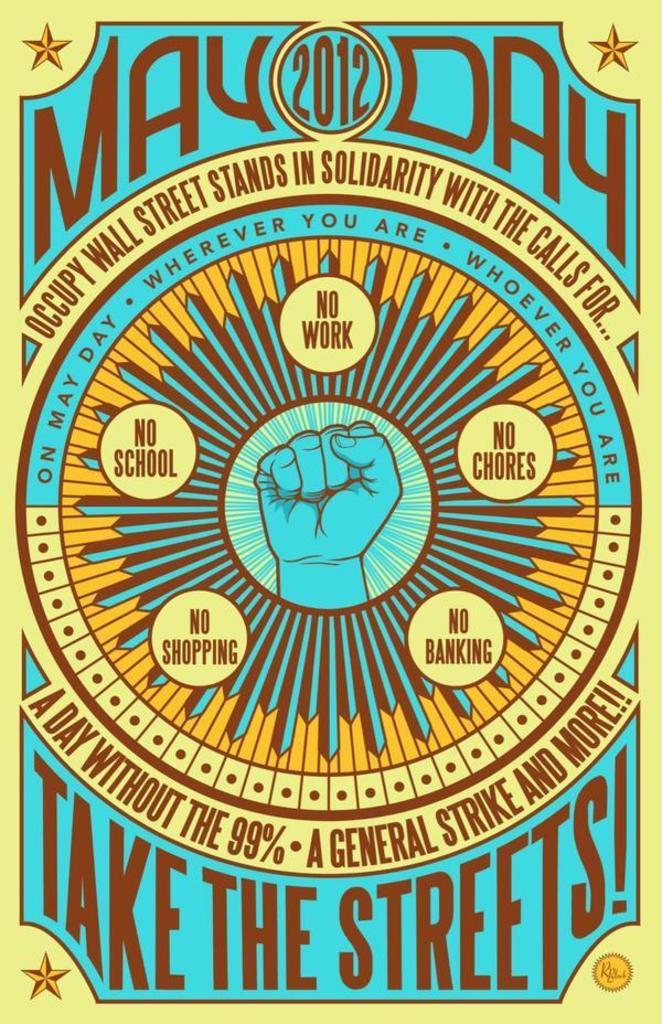<image>
Offer a succinct explanation of the picture presented. Yellow and brown poster that says May Day 2012. 